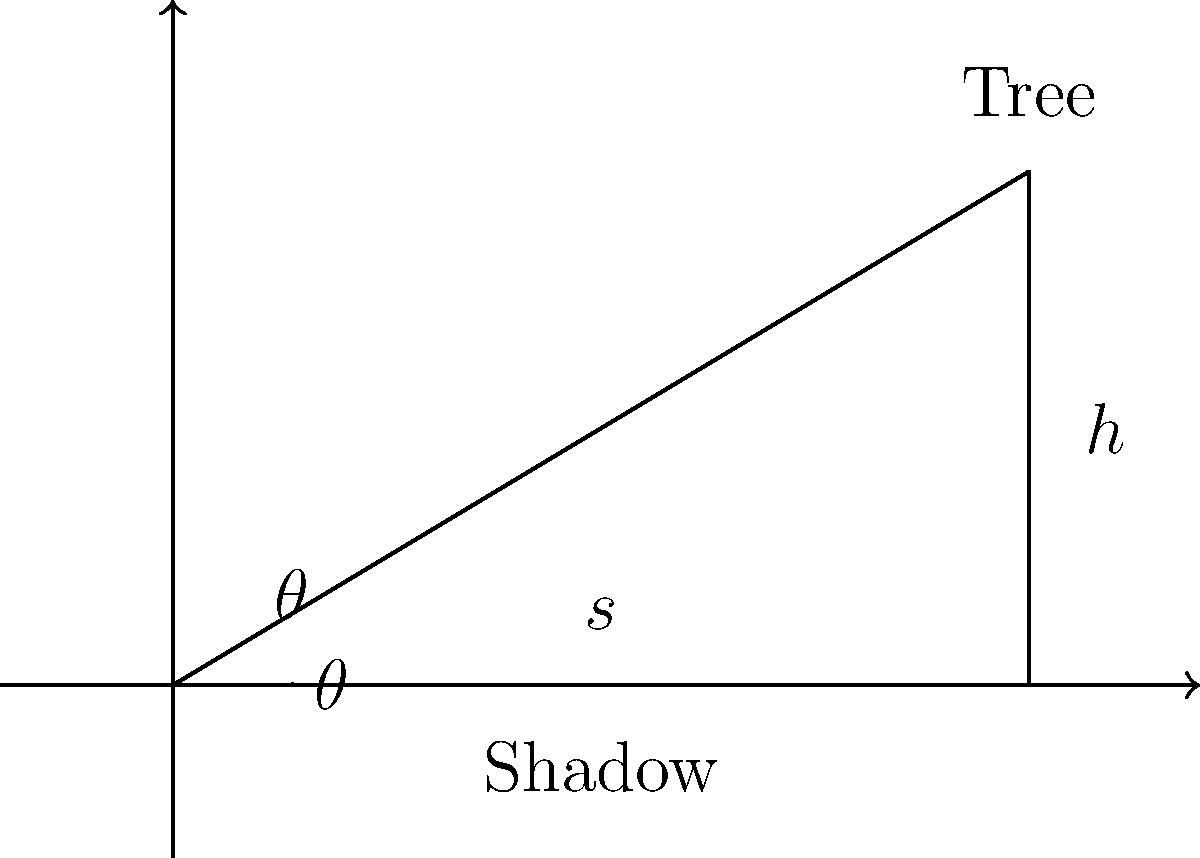As an amateur photographer, you're capturing the beauty of a majestic tree in your local park. To add depth to your photograph's description, you decide to estimate the tree's height. You measure the tree's shadow to be 15 meters long when the angle of elevation of the sun is 35°. Using this information, estimate the height of the tree to the nearest meter. Let's approach this step-by-step:

1) In this scenario, we have a right triangle formed by the tree, its shadow, and the sun's rays.

2) Let $h$ be the height of the tree and $s$ be the length of the shadow.

3) We know that $s = 15$ meters and the angle of elevation $\theta = 35°$.

4) In a right triangle, $\tan(\theta) = \frac{\text{opposite}}{\text{adjacent}} = \frac{h}{s}$

5) Therefore, $h = s \times \tan(\theta)$

6) Plugging in our values:
   $h = 15 \times \tan(35°)$

7) Using a calculator or trigonometric tables:
   $\tan(35°) \approx 0.7002$

8) So, $h = 15 \times 0.7002 = 10.503$ meters

9) Rounding to the nearest meter: $h \approx 11$ meters
Answer: 11 meters 